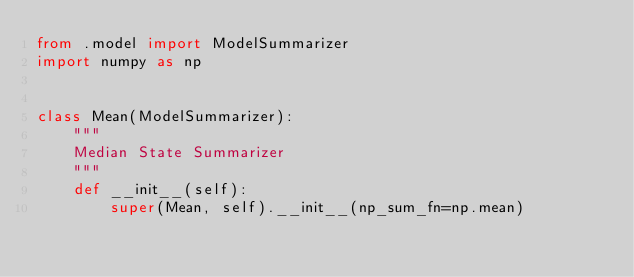Convert code to text. <code><loc_0><loc_0><loc_500><loc_500><_Python_>from .model import ModelSummarizer
import numpy as np


class Mean(ModelSummarizer):
    """
    Median State Summarizer
    """
    def __init__(self):
        super(Mean, self).__init__(np_sum_fn=np.mean)</code> 